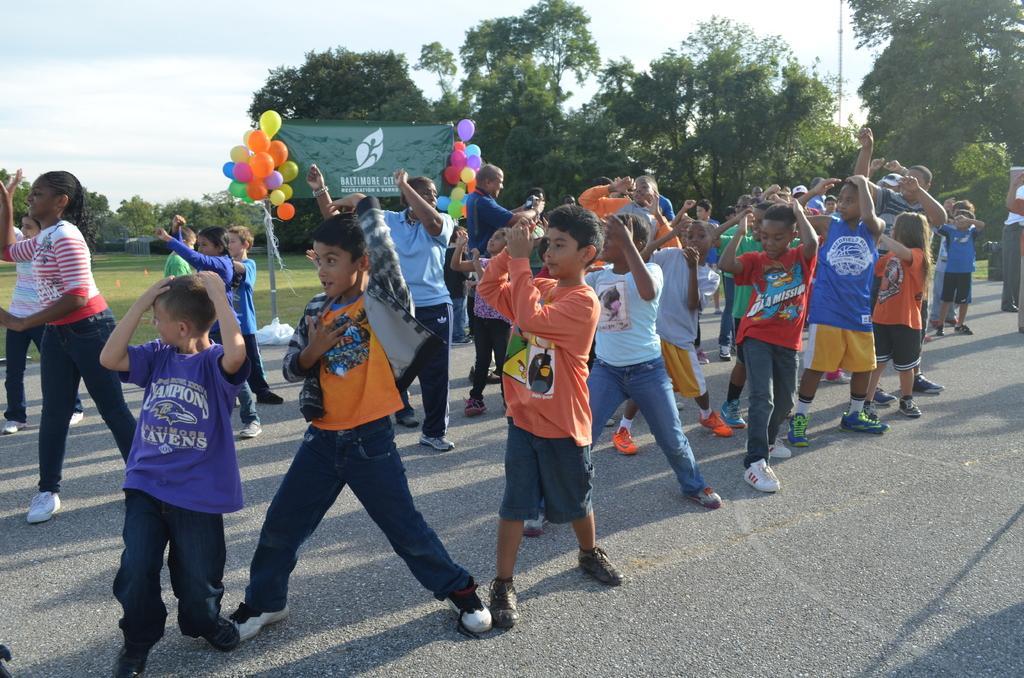Can you describe this image briefly? In this picture I can observe some children on the road. There are some balloons and a poster behind the children. The balloons are in different colors. In the background I can observe some trees and a sky. 